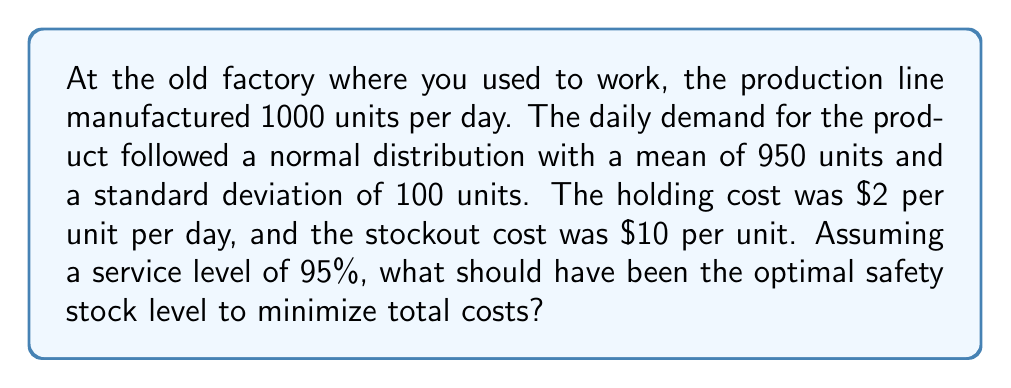What is the answer to this math problem? To solve this problem, we'll follow these steps:

1) First, we need to determine the z-score for a 95% service level. From the standard normal distribution table, we find that the z-score for 95% is approximately 1.645.

2) The safety stock formula is:

   $$ \text{Safety Stock} = z \times \sigma \times \sqrt{L} $$

   Where:
   $z$ is the z-score for the desired service level
   $\sigma$ is the standard deviation of daily demand
   $L$ is the lead time (in this case, 1 day as we're dealing with daily production and demand)

3) Plugging in our values:

   $$ \text{Safety Stock} = 1.645 \times 100 \times \sqrt{1} = 164.5 $$

4) Since we can't have a fractional number of units, we round up to 165 units.

This safety stock level ensures that 95% of the time, the factory would have had enough inventory to meet demand, while minimizing the combined costs of holding excess inventory and potential stockouts.
Answer: The optimal safety stock level should have been 165 units. 